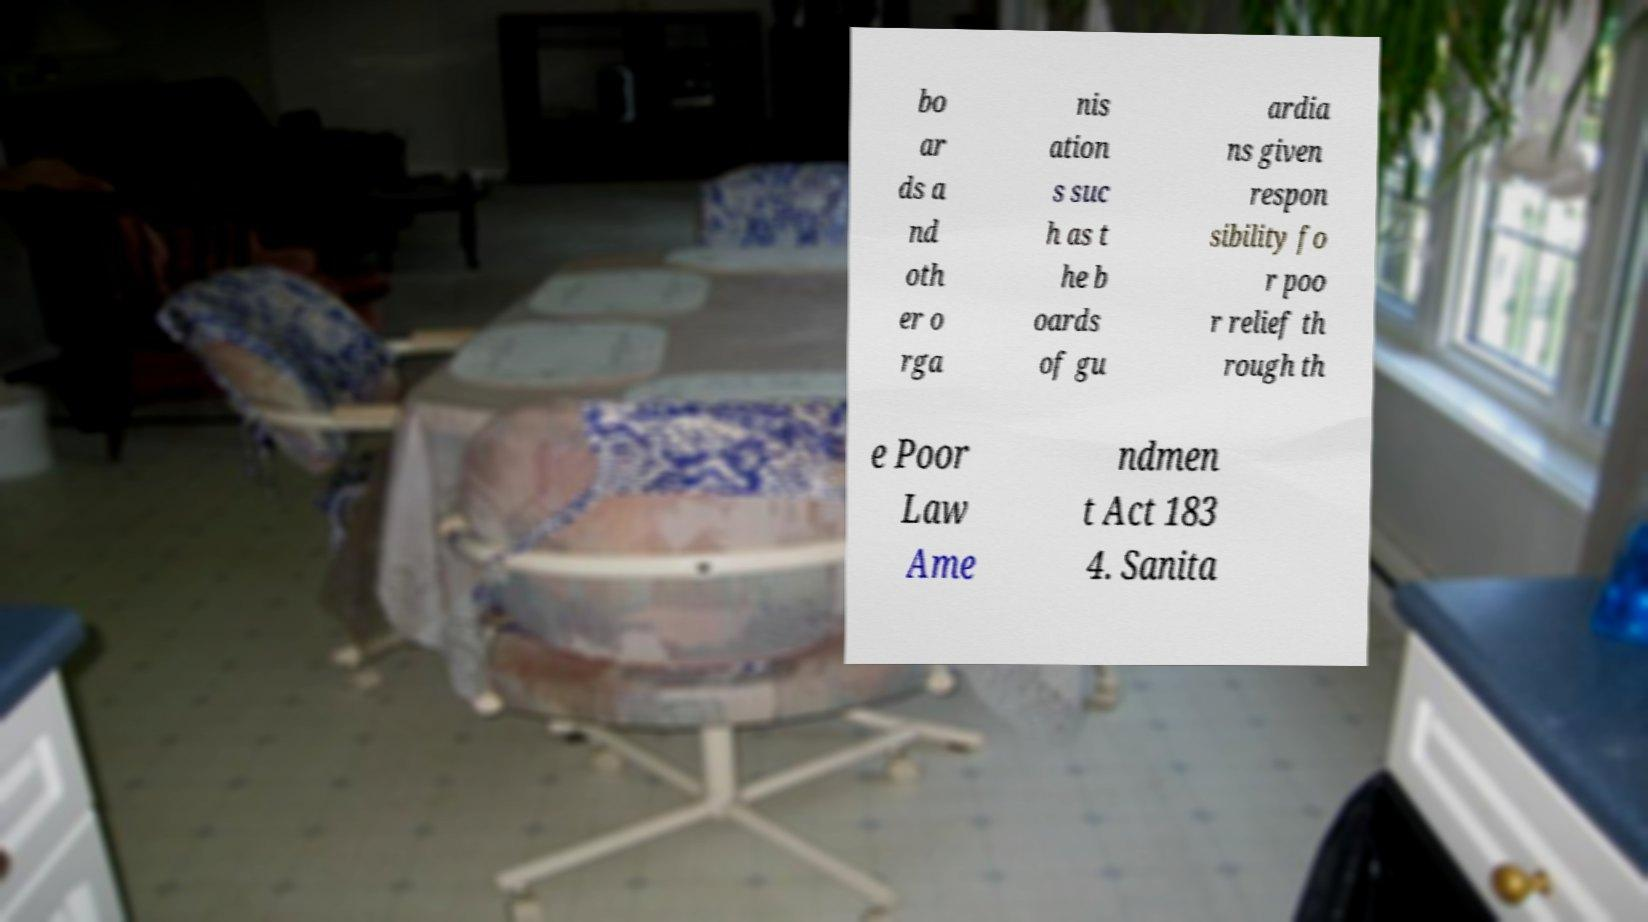Can you accurately transcribe the text from the provided image for me? bo ar ds a nd oth er o rga nis ation s suc h as t he b oards of gu ardia ns given respon sibility fo r poo r relief th rough th e Poor Law Ame ndmen t Act 183 4. Sanita 